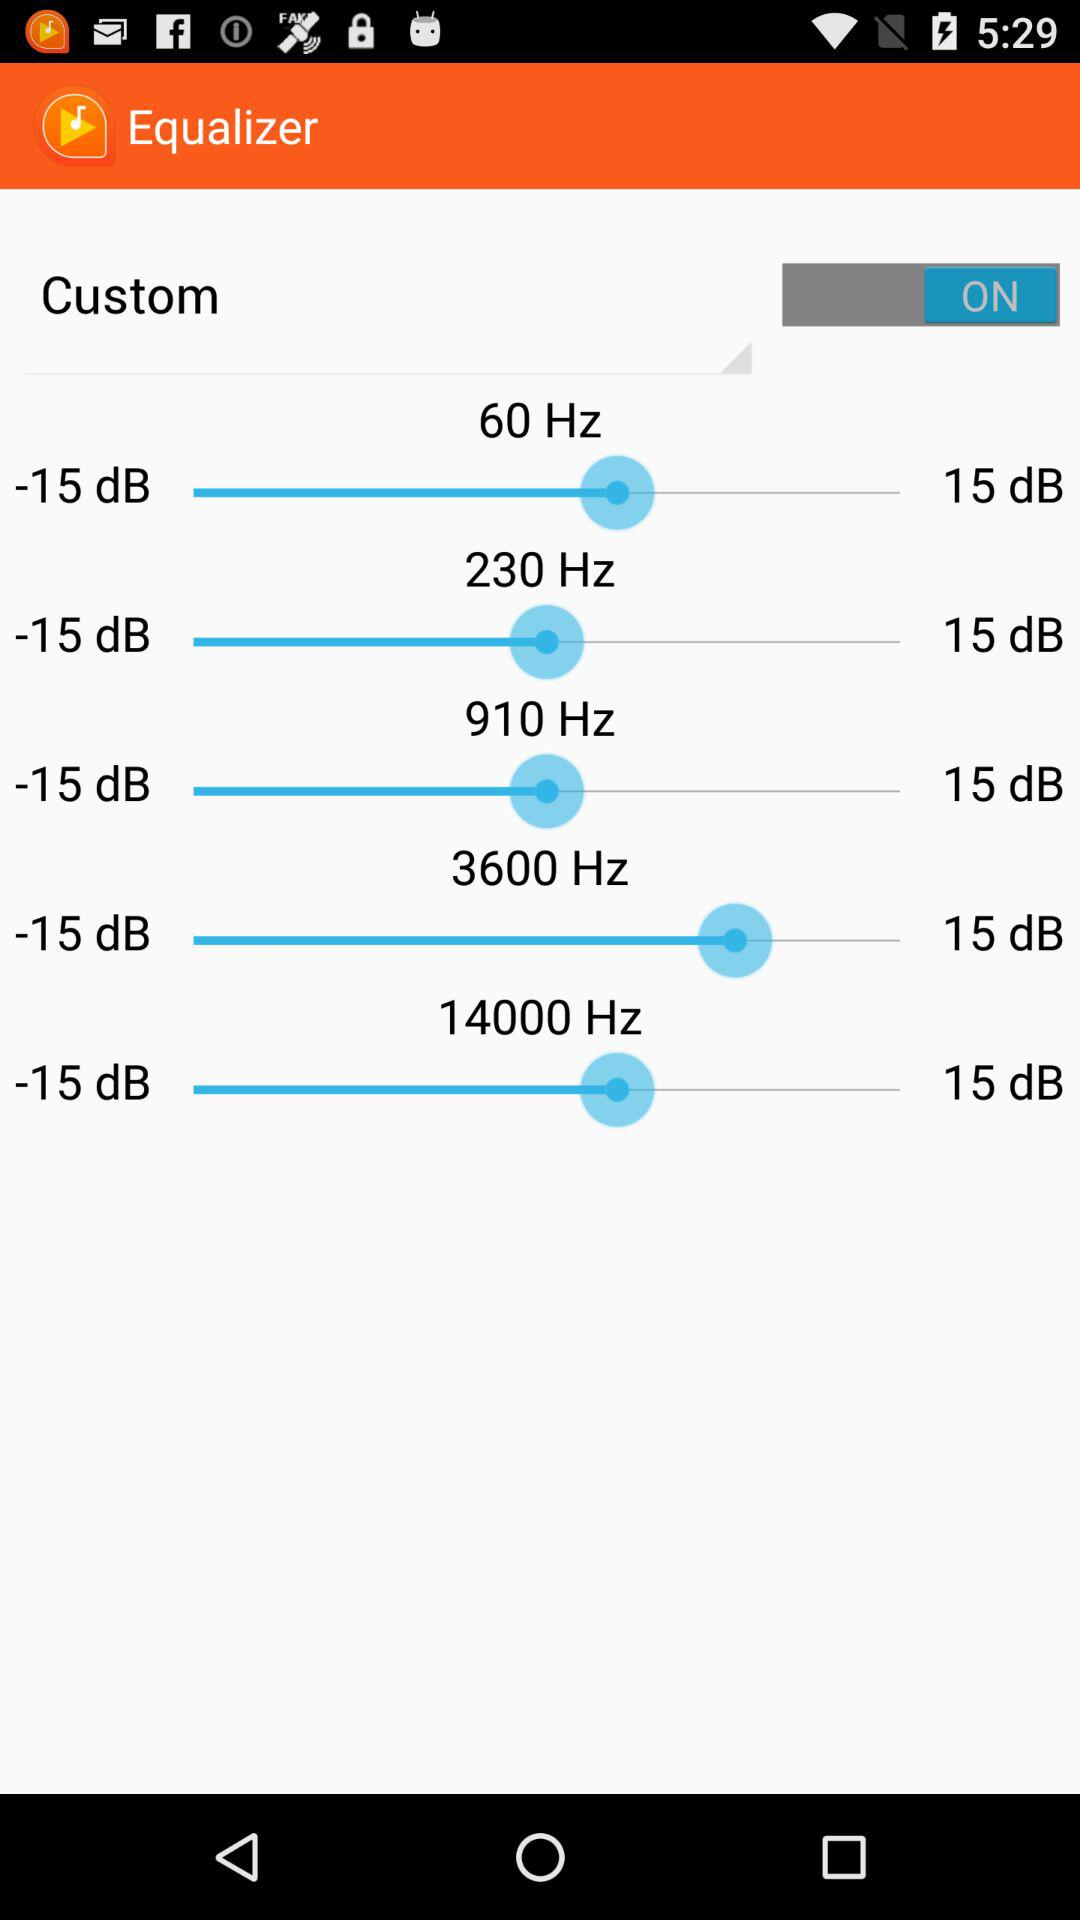What is the status of "Custom"? The status is "on". 